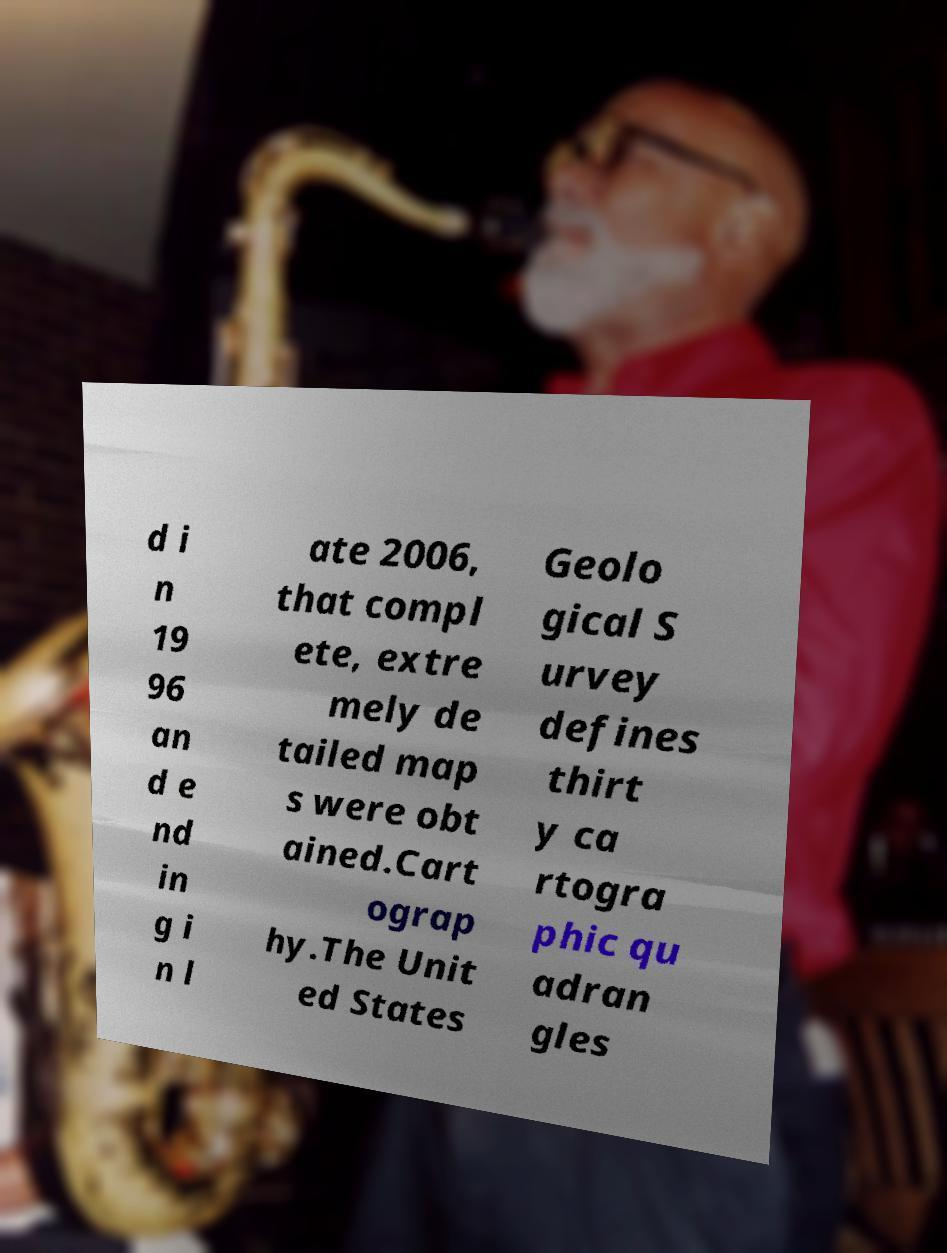Could you extract and type out the text from this image? d i n 19 96 an d e nd in g i n l ate 2006, that compl ete, extre mely de tailed map s were obt ained.Cart ograp hy.The Unit ed States Geolo gical S urvey defines thirt y ca rtogra phic qu adran gles 